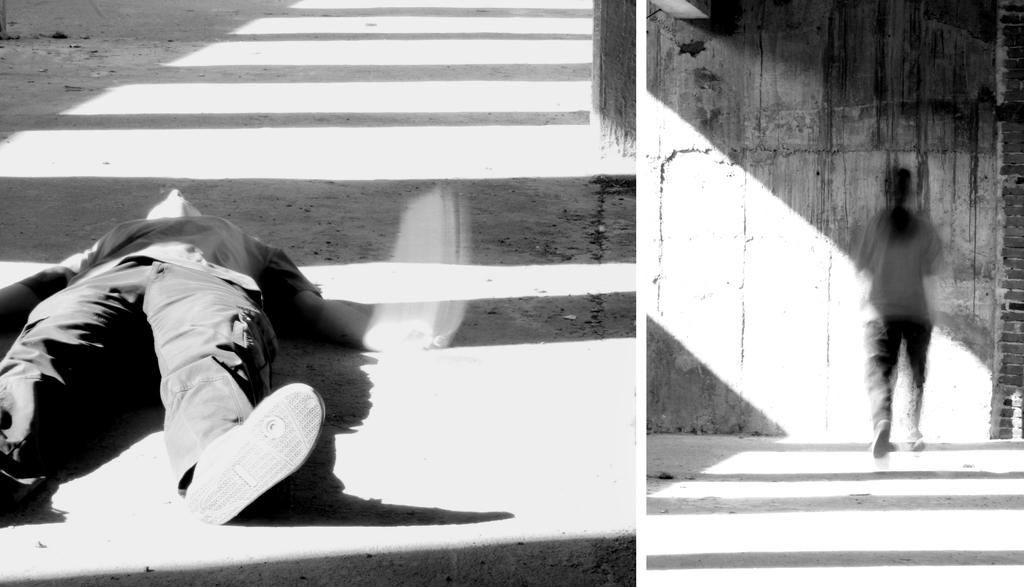What is the color scheme of the image? The image is black and white. What is the main subject of the image? There is a collage of a person's face in the image. What type of suit is the person wearing in the image? There is no suit visible in the image, as it is a black and white collage of a person's face. How many tickets can be seen in the image? There are no tickets present in the image; it is a collage of a person's face. 